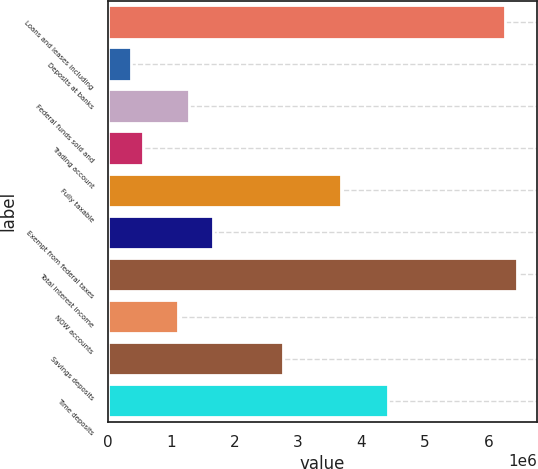Convert chart to OTSL. <chart><loc_0><loc_0><loc_500><loc_500><bar_chart><fcel>Loans and leases including<fcel>Deposits at banks<fcel>Federal funds sold and<fcel>Trading account<fcel>Fully taxable<fcel>Exempt from federal taxes<fcel>Total interest income<fcel>NOW accounts<fcel>Savings deposits<fcel>Time deposits<nl><fcel>6.26313e+06<fcel>368424<fcel>1.28947e+06<fcel>552633<fcel>3.68419e+06<fcel>1.65789e+06<fcel>6.44733e+06<fcel>1.10526e+06<fcel>2.76315e+06<fcel>4.42103e+06<nl></chart> 